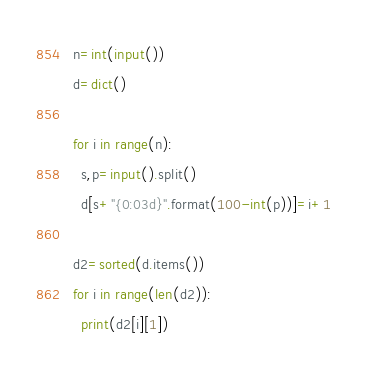<code> <loc_0><loc_0><loc_500><loc_500><_Python_>n=int(input())
d=dict()

for i in range(n):
  s,p=input().split()
  d[s+"{0:03d}".format(100-int(p))]=i+1

d2=sorted(d.items())
for i in range(len(d2)):
  print(d2[i][1])
</code> 